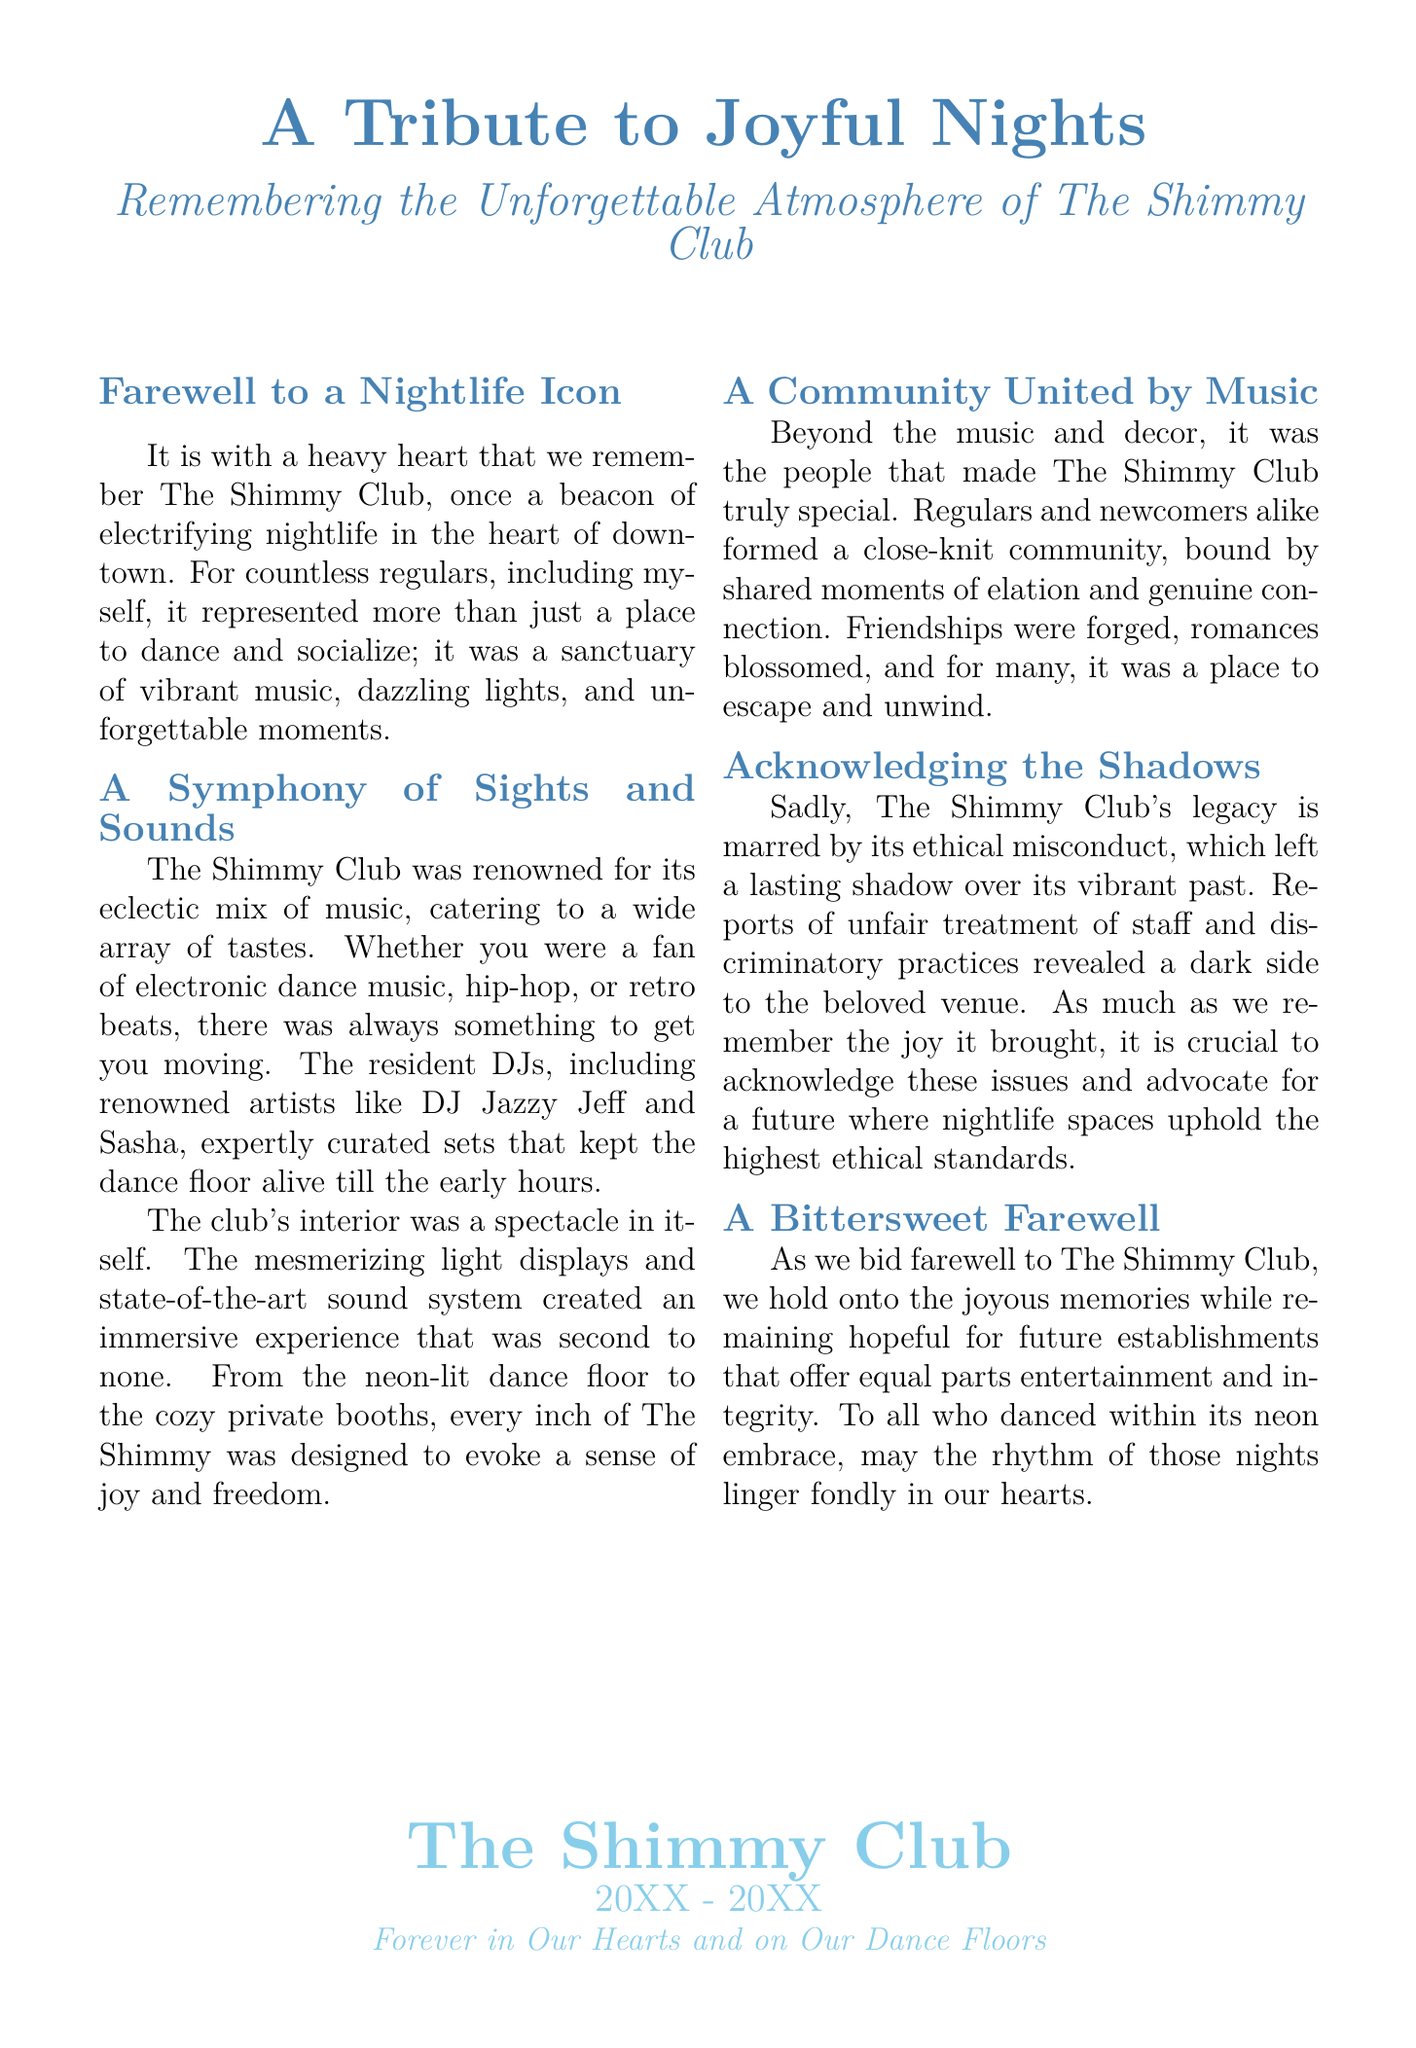what was The Shimmy Club known for? The Shimmy Club was renowned for its eclectic mix of music, catering to a wide array of tastes.
Answer: eclectic mix of music who were some of the resident DJs mentioned? The document mentions renowned artists who were resident DJs.
Answer: DJ Jazzy Jeff and Sasha what kind of atmosphere did The Shimmy Club aim to create? The Shimmy Club was designed to evoke a sense of joy and freedom.
Answer: joy and freedom what ethical issue is acknowledged in the document? The document mentions reports of unfair treatment of staff and discriminatory practices.
Answer: ethical misconduct when did The Shimmy Club operate? The document states the club was open from a certain year to another year, indicated as 20XX to 20XX.
Answer: 20XX - 20XX what is the tone towards the memories of The Shimmy Club? The document reflects a bittersweet feeling towards the memories of The Shimmy Club.
Answer: bittersweet why is it important to acknowledge the club's ethical misconduct? The importance lies in advocating for future nightlife spaces to uphold the highest ethical standards.
Answer: advocate for future integrity how did the club contribute to community building? The document implies it was a place for friendships to be forged and connections made.
Answer: friendships were forged what emotion does the farewell express? The farewell expresses a mixture of sadness and hope for the future.
Answer: sadness and hope 